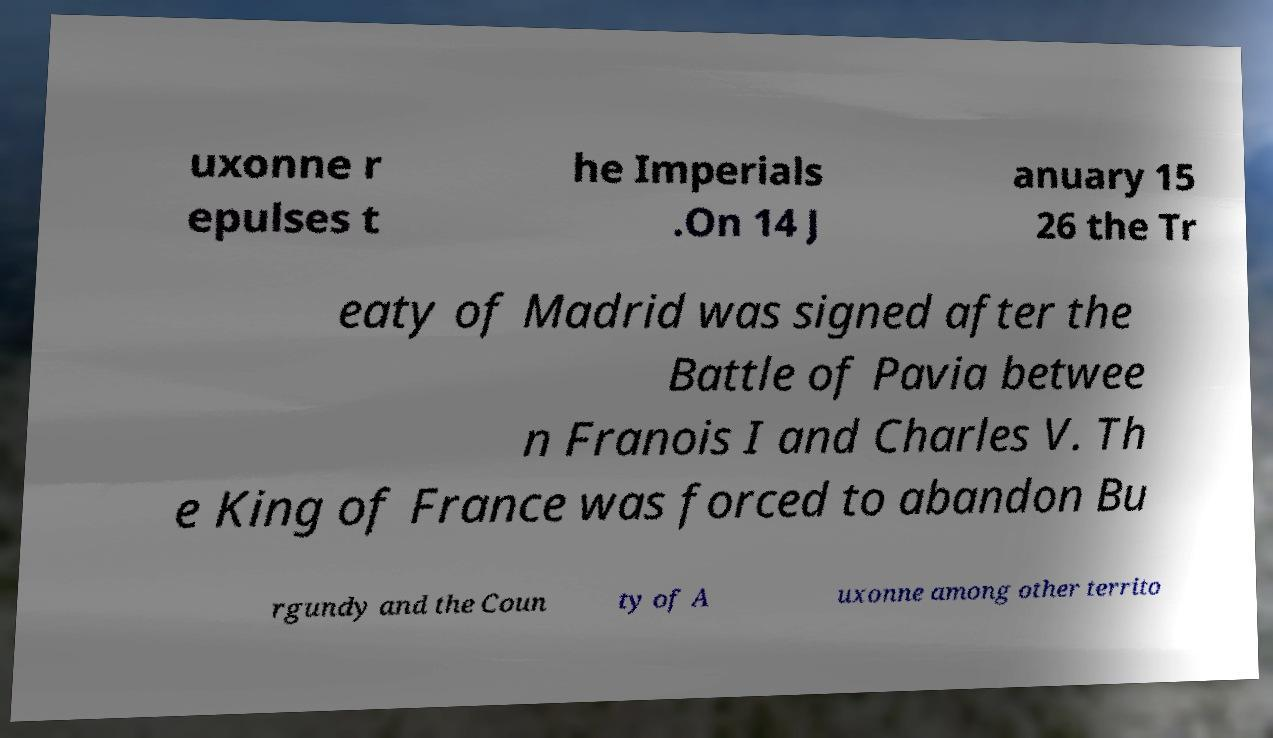Please read and relay the text visible in this image. What does it say? uxonne r epulses t he Imperials .On 14 J anuary 15 26 the Tr eaty of Madrid was signed after the Battle of Pavia betwee n Franois I and Charles V. Th e King of France was forced to abandon Bu rgundy and the Coun ty of A uxonne among other territo 